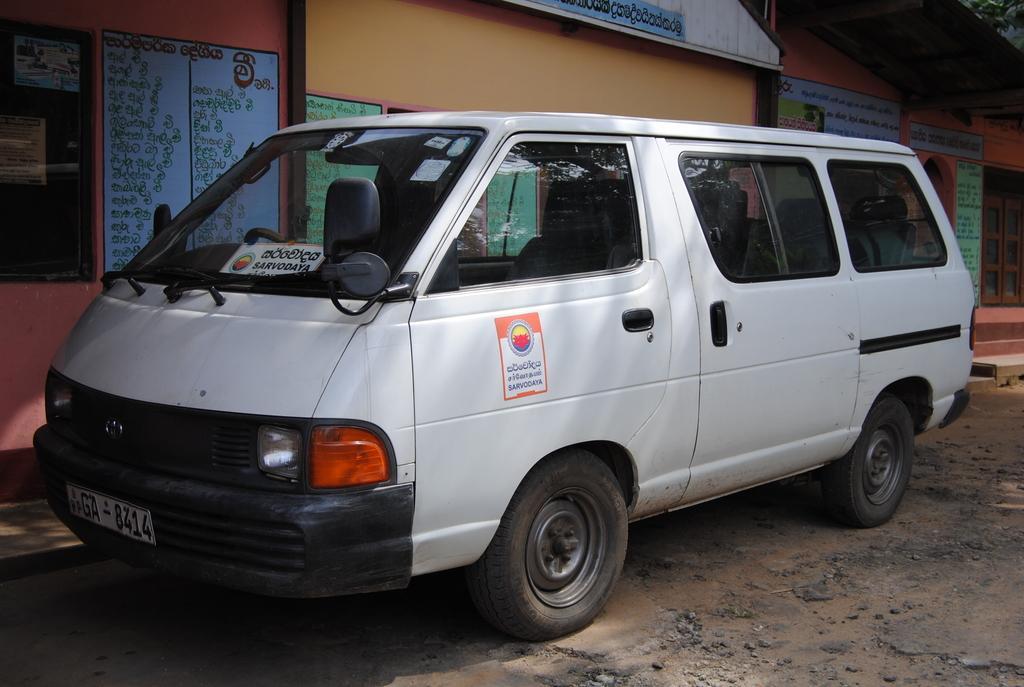How would you summarize this image in a sentence or two? In the picture there is a vehicle, there are houses present, there are walls, on the walls there is some text. 